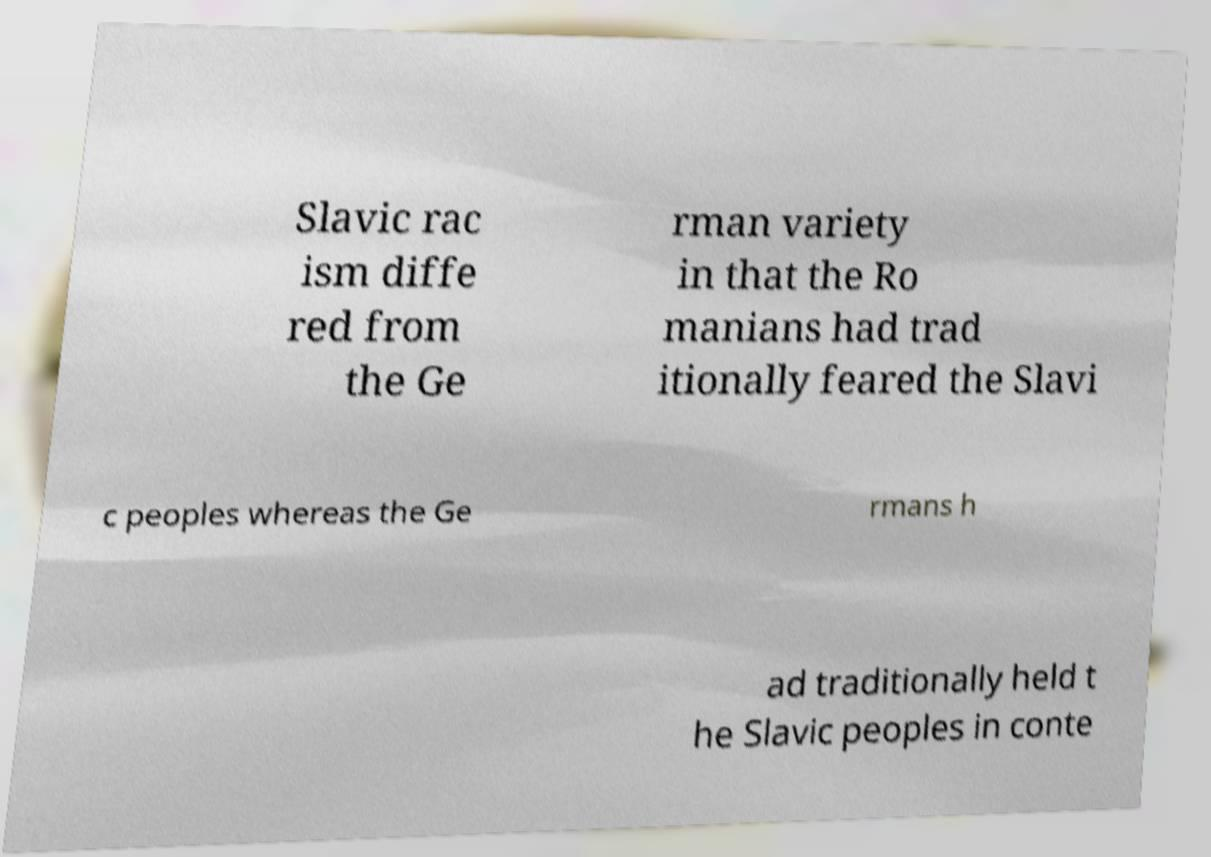Could you assist in decoding the text presented in this image and type it out clearly? Slavic rac ism diffe red from the Ge rman variety in that the Ro manians had trad itionally feared the Slavi c peoples whereas the Ge rmans h ad traditionally held t he Slavic peoples in conte 